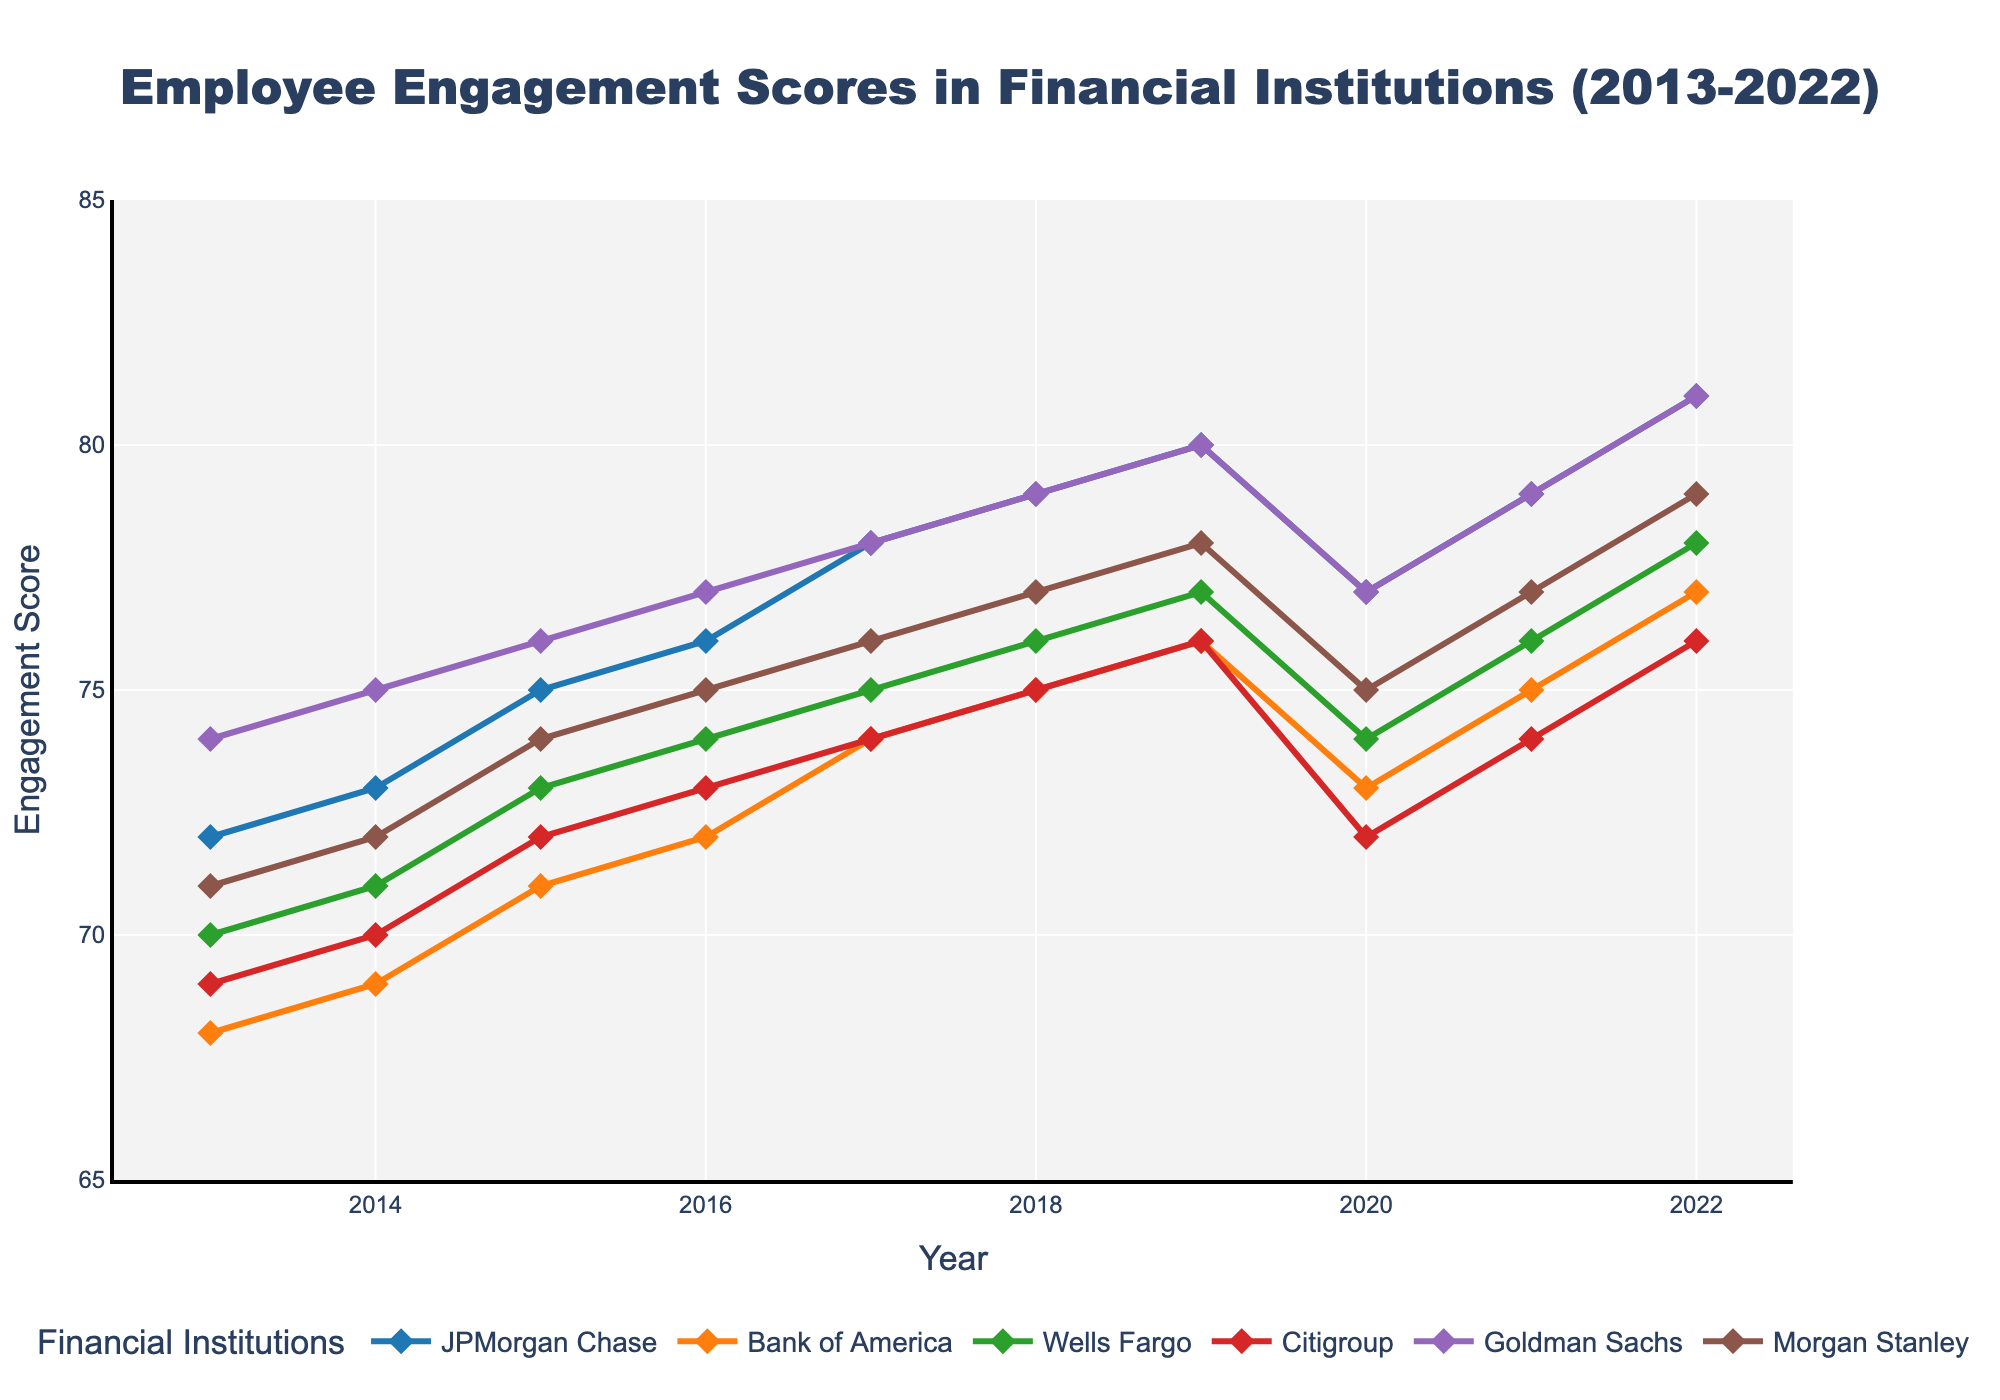What is the average engagement score of Morgan Stanley over the decade? To find the average, sum all the engagement scores of Morgan Stanley from 2013 to 2022 and then divide by the number of years (10). The scores are [71, 72, 74, 75, 76, 77, 78, 75, 77, 79]. Sum = 74 + 76 + 71 + 75 + 72 + 74 + 76 + 75 + 77 + 79 = 746. Average = 746/10 = 74.6
Answer: 74.6 Which bank had the highest engagement score in 2022? Look at the engagement scores for each bank in 2022 and determine which one is the highest. The scores for 2022 are: JPMorgan Chase: 81, Bank of America: 77, Wells Fargo: 78, Citigroup: 76, Goldman Sachs: 81, Morgan Stanley: 79. Both JPMorgan Chase and Goldman Sachs have the highest score of 81.
Answer: JPMorgan Chase and Goldman Sachs Between 2018 and 2020, which bank had the most significant drop in engagement scores? Calculate the difference between the scores for 2020 and 2018 for each bank and identify the one with the largest negative value. The changes are: JPMorgan Chase: 77 - 79 = -2, Bank of America: 73 - 75 = -2, Wells Fargo: 74 - 76 = -2, Citigroup: 72 - 75 = -3, Goldman Sachs: 77 - 79 = -2, Morgan Stanley: 75 - 77 = -2. Citigroup had the most significant drop of -3.
Answer: Citigroup In which year did JPMorgan Chase have its highest engagement score? Observe JPMorgan Chase's scores for each year and find the highest one. The scores are: 72, 73, 75, 76, 78, 79, 80, 77, 79, 81. The highest score is in 2022, which is 81.
Answer: 2022 From 2014 to 2017, which bank shows a steady increase in its engagement scores every year? Examine the engagement scores for each bank from 2014 to 2017 and identify the one with a consistent year-over-year increase. JPMorgan Chase: 73, 75, 76, 78; Bank of America: 69, 71, 72, 74; Wells Fargo: 71, 73, 74, 75; Citigroup: 70, 72, 73, 74; Goldman Sachs: 75, 76, 77, 78; Morgan Stanley: 72, 74, 75, 76. All banks show a steady increase.
Answer: JPMorgan Chase, Bank of America, Wells Fargo, Citigroup, Goldman Sachs, Morgan Stanley What is the total increase in engagement score for Wells Fargo from 2013 to 2022? Subtract the score for 2013 from the score for 2022 for Wells Fargo to find the increase. The scores are 70 (2013) and 78 (2022). Total increase = 78 - 70 = 8.
Answer: 8 Which bank has the least variation in its engagement scores over the decade? Calculate the range (max score - min score) of engagement scores for each bank and determine which has the smallest range. JPMorgan Chase: 81 - 72 = 9, Bank of America: 77 - 68 = 9, Wells Fargo: 78 - 70 = 8, Citigroup: 76 - 69 = 7, Goldman Sachs: 81 - 74 = 7, Morgan Stanley: 79 - 71 = 8. Citigroup and Goldman Sachs have a range of 7.
Answer: Citigroup and Goldman Sachs In which year did Goldman Sachs achieve its peak engagement score? Identify the highest engagement score for Goldman Sachs and the corresponding year. The scores are: 74, 75, 76, 77, 78, 79, 80, 77, 79, 81. The peak score is 81 in 2022.
Answer: 2022 Compare the engagement scores of JPMorgan Chase and Bank of America in 2016. Which bank had a higher score? Look at the engagement scores of both banks in 2016 and compare them. JPMorgan Chase: 76, Bank of America: 72. JPMorgan Chase had a higher score.
Answer: JPMorgan Chase Which bank showed an engagement score above 75 in every year from 2017 to 2022? Check if each bank's engagement scores from 2017 to 2022 are consistently above 75. JPMorgan Chase: 78, 79, 80, 77, 79, 81; Bank of America: below 75 in 2017, 2018, and 2020; Wells Fargo: scores below 75 in 2017, 2020, and 2021; Citigroup: below 75 every year; Goldman Sachs: 78, 79, 80, 77, 79, 81; Morgan Stanley: below 75 in 2017, 2018, and 2020. Only JPMorgan Chase and Goldman Sachs showed engagement scores consistently above 75 from 2017 to 2022.
Answer: JPMorgan Chase and Goldman Sachs 